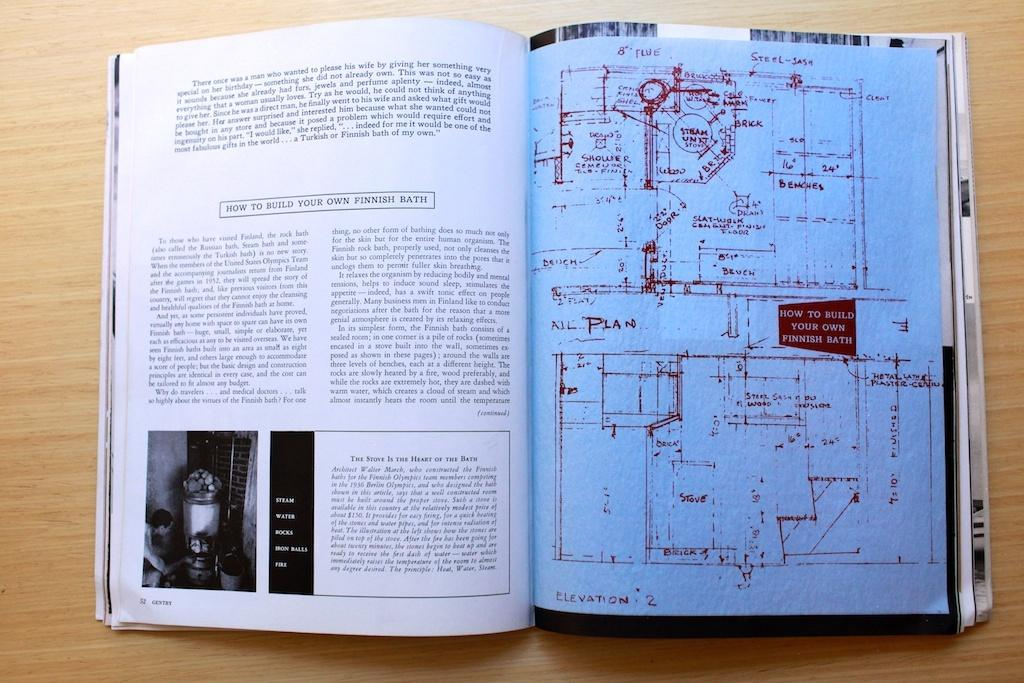<image>
Present a compact description of the photo's key features. an open book with instructions on How To Build Your Own Finnish Bath. 